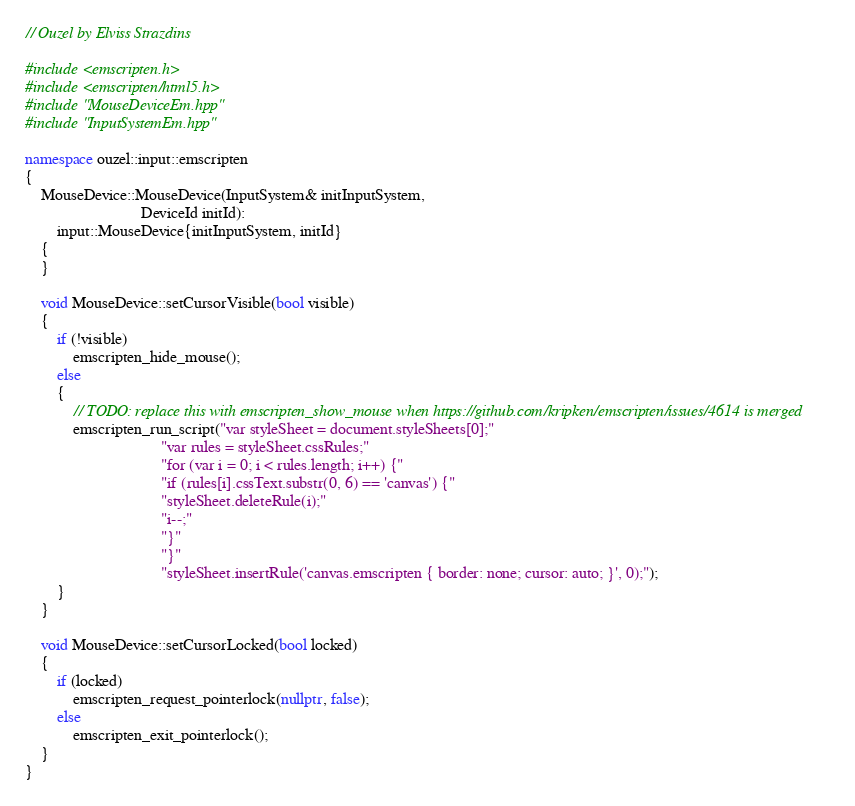<code> <loc_0><loc_0><loc_500><loc_500><_C++_>// Ouzel by Elviss Strazdins

#include <emscripten.h>
#include <emscripten/html5.h>
#include "MouseDeviceEm.hpp"
#include "InputSystemEm.hpp"

namespace ouzel::input::emscripten
{
    MouseDevice::MouseDevice(InputSystem& initInputSystem,
                             DeviceId initId):
        input::MouseDevice{initInputSystem, initId}
    {
    }

    void MouseDevice::setCursorVisible(bool visible)
    {
        if (!visible)
            emscripten_hide_mouse();
        else
        {
            // TODO: replace this with emscripten_show_mouse when https://github.com/kripken/emscripten/issues/4614 is merged
            emscripten_run_script("var styleSheet = document.styleSheets[0];"
                                  "var rules = styleSheet.cssRules;"
                                  "for (var i = 0; i < rules.length; i++) {"
                                  "if (rules[i].cssText.substr(0, 6) == 'canvas') {"
                                  "styleSheet.deleteRule(i);"
                                  "i--;"
                                  "}"
                                  "}"
                                  "styleSheet.insertRule('canvas.emscripten { border: none; cursor: auto; }', 0);");
        }
    }

    void MouseDevice::setCursorLocked(bool locked)
    {
        if (locked)
            emscripten_request_pointerlock(nullptr, false);
        else
            emscripten_exit_pointerlock();
    }
}
</code> 